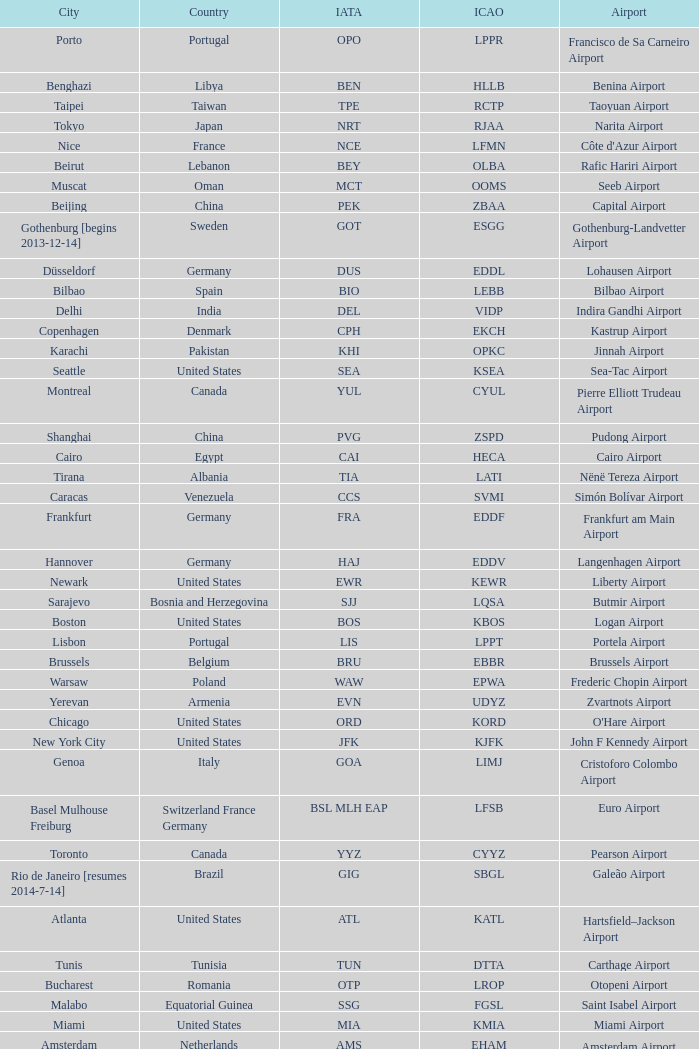Which city has the IATA SSG? Malabo. 